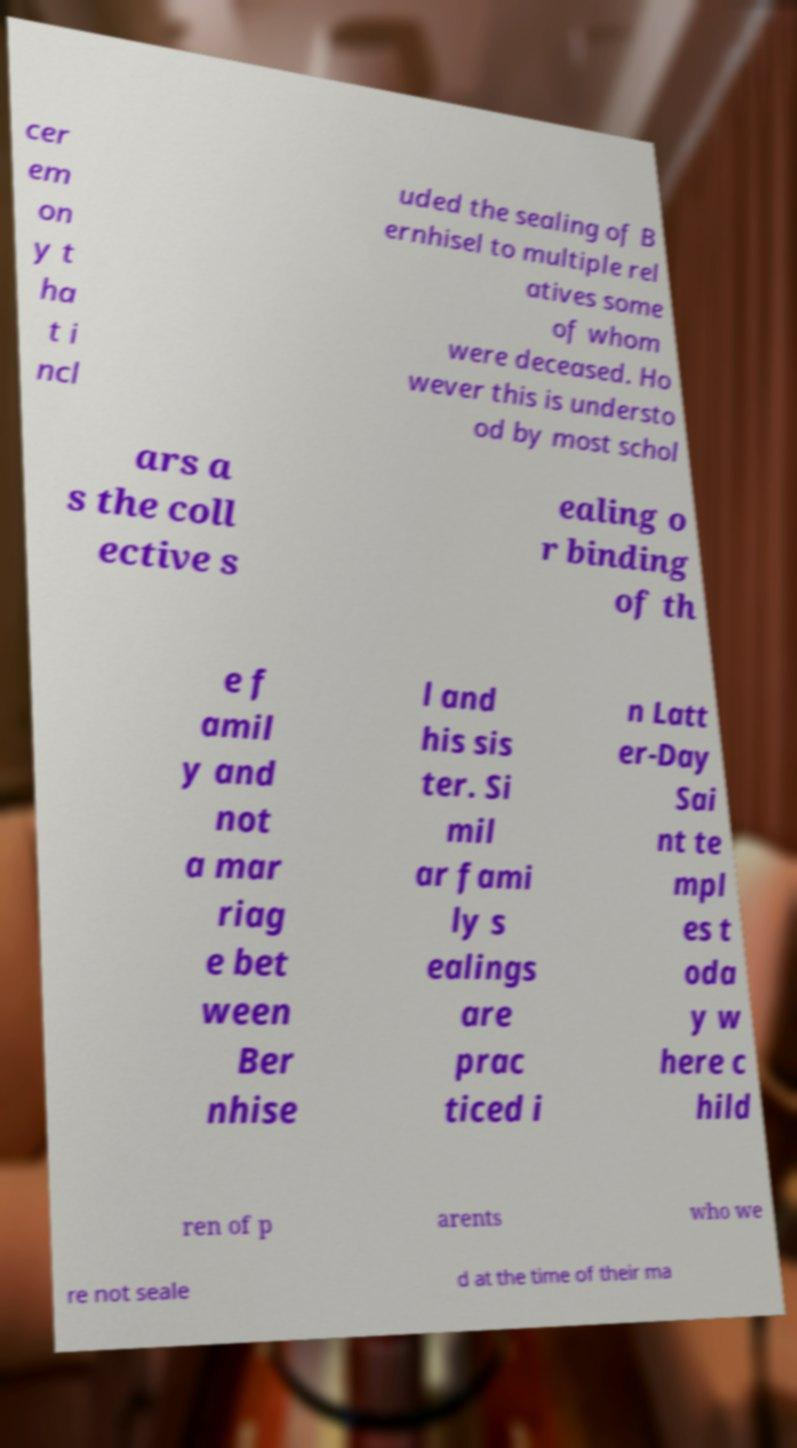What messages or text are displayed in this image? I need them in a readable, typed format. cer em on y t ha t i ncl uded the sealing of B ernhisel to multiple rel atives some of whom were deceased. Ho wever this is understo od by most schol ars a s the coll ective s ealing o r binding of th e f amil y and not a mar riag e bet ween Ber nhise l and his sis ter. Si mil ar fami ly s ealings are prac ticed i n Latt er-Day Sai nt te mpl es t oda y w here c hild ren of p arents who we re not seale d at the time of their ma 